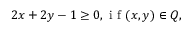Convert formula to latex. <formula><loc_0><loc_0><loc_500><loc_500>2 x + 2 y - 1 \geq 0 , i f ( x , y ) \in Q ,</formula> 